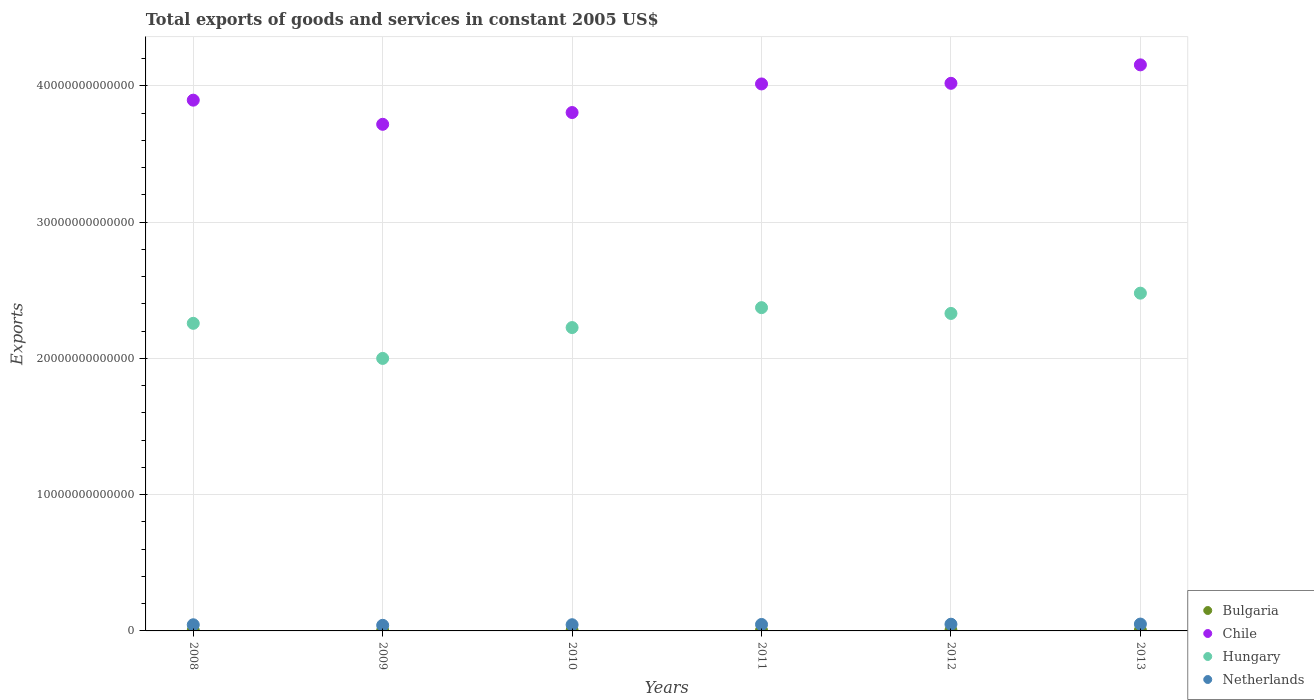How many different coloured dotlines are there?
Give a very brief answer. 4. What is the total exports of goods and services in Netherlands in 2013?
Keep it short and to the point. 5.03e+11. Across all years, what is the maximum total exports of goods and services in Chile?
Provide a short and direct response. 4.15e+13. Across all years, what is the minimum total exports of goods and services in Chile?
Ensure brevity in your answer.  3.72e+13. In which year was the total exports of goods and services in Netherlands maximum?
Provide a short and direct response. 2013. In which year was the total exports of goods and services in Hungary minimum?
Keep it short and to the point. 2009. What is the total total exports of goods and services in Bulgaria in the graph?
Your answer should be compact. 2.49e+11. What is the difference between the total exports of goods and services in Chile in 2012 and that in 2013?
Offer a terse response. -1.35e+12. What is the difference between the total exports of goods and services in Hungary in 2012 and the total exports of goods and services in Netherlands in 2009?
Give a very brief answer. 2.29e+13. What is the average total exports of goods and services in Hungary per year?
Make the answer very short. 2.28e+13. In the year 2012, what is the difference between the total exports of goods and services in Netherlands and total exports of goods and services in Hungary?
Provide a short and direct response. -2.28e+13. In how many years, is the total exports of goods and services in Chile greater than 16000000000000 US$?
Provide a short and direct response. 6. What is the ratio of the total exports of goods and services in Chile in 2009 to that in 2012?
Offer a terse response. 0.93. Is the total exports of goods and services in Netherlands in 2009 less than that in 2011?
Give a very brief answer. Yes. Is the difference between the total exports of goods and services in Netherlands in 2012 and 2013 greater than the difference between the total exports of goods and services in Hungary in 2012 and 2013?
Keep it short and to the point. Yes. What is the difference between the highest and the second highest total exports of goods and services in Bulgaria?
Offer a terse response. 4.09e+09. What is the difference between the highest and the lowest total exports of goods and services in Bulgaria?
Offer a terse response. 1.48e+1. Is the sum of the total exports of goods and services in Hungary in 2008 and 2010 greater than the maximum total exports of goods and services in Netherlands across all years?
Your answer should be compact. Yes. Is it the case that in every year, the sum of the total exports of goods and services in Chile and total exports of goods and services in Hungary  is greater than the total exports of goods and services in Netherlands?
Keep it short and to the point. Yes. Is the total exports of goods and services in Bulgaria strictly greater than the total exports of goods and services in Hungary over the years?
Your response must be concise. No. How many dotlines are there?
Offer a terse response. 4. How many years are there in the graph?
Ensure brevity in your answer.  6. What is the difference between two consecutive major ticks on the Y-axis?
Provide a short and direct response. 1.00e+13. Are the values on the major ticks of Y-axis written in scientific E-notation?
Your answer should be compact. No. Does the graph contain any zero values?
Offer a very short reply. No. Does the graph contain grids?
Ensure brevity in your answer.  Yes. How many legend labels are there?
Your response must be concise. 4. What is the title of the graph?
Your response must be concise. Total exports of goods and services in constant 2005 US$. What is the label or title of the Y-axis?
Provide a short and direct response. Exports. What is the Exports in Bulgaria in 2008?
Keep it short and to the point. 3.83e+1. What is the Exports in Chile in 2008?
Keep it short and to the point. 3.90e+13. What is the Exports of Hungary in 2008?
Your answer should be very brief. 2.26e+13. What is the Exports in Netherlands in 2008?
Offer a very short reply. 4.51e+11. What is the Exports of Bulgaria in 2009?
Ensure brevity in your answer.  3.38e+1. What is the Exports in Chile in 2009?
Ensure brevity in your answer.  3.72e+13. What is the Exports in Hungary in 2009?
Offer a terse response. 2.00e+13. What is the Exports in Netherlands in 2009?
Keep it short and to the point. 4.11e+11. What is the Exports in Bulgaria in 2010?
Offer a very short reply. 3.96e+1. What is the Exports of Chile in 2010?
Your response must be concise. 3.80e+13. What is the Exports in Hungary in 2010?
Give a very brief answer. 2.23e+13. What is the Exports in Netherlands in 2010?
Provide a short and direct response. 4.54e+11. What is the Exports of Bulgaria in 2011?
Your answer should be compact. 4.42e+1. What is the Exports of Chile in 2011?
Your response must be concise. 4.01e+13. What is the Exports in Hungary in 2011?
Give a very brief answer. 2.37e+13. What is the Exports of Netherlands in 2011?
Offer a terse response. 4.74e+11. What is the Exports in Bulgaria in 2012?
Your answer should be compact. 4.46e+1. What is the Exports in Chile in 2012?
Make the answer very short. 4.02e+13. What is the Exports in Hungary in 2012?
Give a very brief answer. 2.33e+13. What is the Exports in Netherlands in 2012?
Your answer should be compact. 4.92e+11. What is the Exports of Bulgaria in 2013?
Ensure brevity in your answer.  4.86e+1. What is the Exports of Chile in 2013?
Your answer should be compact. 4.15e+13. What is the Exports in Hungary in 2013?
Your response must be concise. 2.48e+13. What is the Exports of Netherlands in 2013?
Give a very brief answer. 5.03e+11. Across all years, what is the maximum Exports of Bulgaria?
Offer a very short reply. 4.86e+1. Across all years, what is the maximum Exports of Chile?
Make the answer very short. 4.15e+13. Across all years, what is the maximum Exports of Hungary?
Make the answer very short. 2.48e+13. Across all years, what is the maximum Exports of Netherlands?
Ensure brevity in your answer.  5.03e+11. Across all years, what is the minimum Exports in Bulgaria?
Your answer should be compact. 3.38e+1. Across all years, what is the minimum Exports of Chile?
Provide a succinct answer. 3.72e+13. Across all years, what is the minimum Exports of Hungary?
Keep it short and to the point. 2.00e+13. Across all years, what is the minimum Exports of Netherlands?
Give a very brief answer. 4.11e+11. What is the total Exports of Bulgaria in the graph?
Make the answer very short. 2.49e+11. What is the total Exports in Chile in the graph?
Make the answer very short. 2.36e+14. What is the total Exports of Hungary in the graph?
Your answer should be compact. 1.37e+14. What is the total Exports of Netherlands in the graph?
Make the answer very short. 2.79e+12. What is the difference between the Exports of Bulgaria in 2008 and that in 2009?
Provide a succinct answer. 4.49e+09. What is the difference between the Exports in Chile in 2008 and that in 2009?
Make the answer very short. 1.77e+12. What is the difference between the Exports of Hungary in 2008 and that in 2009?
Provide a short and direct response. 2.58e+12. What is the difference between the Exports in Netherlands in 2008 and that in 2009?
Provide a succinct answer. 4.02e+1. What is the difference between the Exports of Bulgaria in 2008 and that in 2010?
Offer a very short reply. -1.33e+09. What is the difference between the Exports of Chile in 2008 and that in 2010?
Offer a terse response. 9.08e+11. What is the difference between the Exports of Hungary in 2008 and that in 2010?
Your response must be concise. 3.11e+11. What is the difference between the Exports of Netherlands in 2008 and that in 2010?
Provide a short and direct response. -3.14e+09. What is the difference between the Exports in Bulgaria in 2008 and that in 2011?
Your response must be concise. -5.89e+09. What is the difference between the Exports in Chile in 2008 and that in 2011?
Offer a very short reply. -1.19e+12. What is the difference between the Exports of Hungary in 2008 and that in 2011?
Make the answer very short. -1.15e+12. What is the difference between the Exports of Netherlands in 2008 and that in 2011?
Provide a succinct answer. -2.32e+1. What is the difference between the Exports in Bulgaria in 2008 and that in 2012?
Keep it short and to the point. -6.23e+09. What is the difference between the Exports in Chile in 2008 and that in 2012?
Provide a succinct answer. -1.24e+12. What is the difference between the Exports in Hungary in 2008 and that in 2012?
Your response must be concise. -7.25e+11. What is the difference between the Exports in Netherlands in 2008 and that in 2012?
Your answer should be compact. -4.11e+1. What is the difference between the Exports of Bulgaria in 2008 and that in 2013?
Provide a succinct answer. -1.03e+1. What is the difference between the Exports of Chile in 2008 and that in 2013?
Your answer should be very brief. -2.59e+12. What is the difference between the Exports in Hungary in 2008 and that in 2013?
Provide a succinct answer. -2.21e+12. What is the difference between the Exports of Netherlands in 2008 and that in 2013?
Offer a terse response. -5.17e+1. What is the difference between the Exports of Bulgaria in 2009 and that in 2010?
Keep it short and to the point. -5.82e+09. What is the difference between the Exports of Chile in 2009 and that in 2010?
Give a very brief answer. -8.64e+11. What is the difference between the Exports in Hungary in 2009 and that in 2010?
Provide a succinct answer. -2.26e+12. What is the difference between the Exports of Netherlands in 2009 and that in 2010?
Your response must be concise. -4.33e+1. What is the difference between the Exports of Bulgaria in 2009 and that in 2011?
Offer a very short reply. -1.04e+1. What is the difference between the Exports of Chile in 2009 and that in 2011?
Your answer should be very brief. -2.96e+12. What is the difference between the Exports in Hungary in 2009 and that in 2011?
Your response must be concise. -3.73e+12. What is the difference between the Exports of Netherlands in 2009 and that in 2011?
Your answer should be compact. -6.33e+1. What is the difference between the Exports of Bulgaria in 2009 and that in 2012?
Make the answer very short. -1.07e+1. What is the difference between the Exports in Chile in 2009 and that in 2012?
Provide a succinct answer. -3.01e+12. What is the difference between the Exports in Hungary in 2009 and that in 2012?
Provide a succinct answer. -3.30e+12. What is the difference between the Exports in Netherlands in 2009 and that in 2012?
Provide a succinct answer. -8.13e+1. What is the difference between the Exports of Bulgaria in 2009 and that in 2013?
Make the answer very short. -1.48e+1. What is the difference between the Exports in Chile in 2009 and that in 2013?
Your answer should be very brief. -4.36e+12. What is the difference between the Exports in Hungary in 2009 and that in 2013?
Your response must be concise. -4.79e+12. What is the difference between the Exports of Netherlands in 2009 and that in 2013?
Your answer should be very brief. -9.19e+1. What is the difference between the Exports of Bulgaria in 2010 and that in 2011?
Keep it short and to the point. -4.56e+09. What is the difference between the Exports of Chile in 2010 and that in 2011?
Offer a terse response. -2.10e+12. What is the difference between the Exports in Hungary in 2010 and that in 2011?
Your answer should be compact. -1.46e+12. What is the difference between the Exports of Netherlands in 2010 and that in 2011?
Ensure brevity in your answer.  -2.00e+1. What is the difference between the Exports in Bulgaria in 2010 and that in 2012?
Keep it short and to the point. -4.91e+09. What is the difference between the Exports of Chile in 2010 and that in 2012?
Offer a very short reply. -2.14e+12. What is the difference between the Exports of Hungary in 2010 and that in 2012?
Offer a terse response. -1.04e+12. What is the difference between the Exports of Netherlands in 2010 and that in 2012?
Your answer should be very brief. -3.80e+1. What is the difference between the Exports in Bulgaria in 2010 and that in 2013?
Keep it short and to the point. -9.00e+09. What is the difference between the Exports of Chile in 2010 and that in 2013?
Your answer should be compact. -3.50e+12. What is the difference between the Exports of Hungary in 2010 and that in 2013?
Make the answer very short. -2.52e+12. What is the difference between the Exports of Netherlands in 2010 and that in 2013?
Provide a short and direct response. -4.86e+1. What is the difference between the Exports in Bulgaria in 2011 and that in 2012?
Your answer should be very brief. -3.45e+08. What is the difference between the Exports in Chile in 2011 and that in 2012?
Make the answer very short. -4.56e+1. What is the difference between the Exports in Hungary in 2011 and that in 2012?
Ensure brevity in your answer.  4.25e+11. What is the difference between the Exports in Netherlands in 2011 and that in 2012?
Make the answer very short. -1.80e+1. What is the difference between the Exports of Bulgaria in 2011 and that in 2013?
Offer a terse response. -4.44e+09. What is the difference between the Exports of Chile in 2011 and that in 2013?
Your answer should be very brief. -1.40e+12. What is the difference between the Exports of Hungary in 2011 and that in 2013?
Keep it short and to the point. -1.06e+12. What is the difference between the Exports of Netherlands in 2011 and that in 2013?
Your answer should be compact. -2.86e+1. What is the difference between the Exports of Bulgaria in 2012 and that in 2013?
Ensure brevity in your answer.  -4.09e+09. What is the difference between the Exports of Chile in 2012 and that in 2013?
Your answer should be compact. -1.35e+12. What is the difference between the Exports in Hungary in 2012 and that in 2013?
Your response must be concise. -1.49e+12. What is the difference between the Exports in Netherlands in 2012 and that in 2013?
Provide a short and direct response. -1.06e+1. What is the difference between the Exports of Bulgaria in 2008 and the Exports of Chile in 2009?
Your response must be concise. -3.71e+13. What is the difference between the Exports of Bulgaria in 2008 and the Exports of Hungary in 2009?
Your answer should be very brief. -2.00e+13. What is the difference between the Exports in Bulgaria in 2008 and the Exports in Netherlands in 2009?
Make the answer very short. -3.73e+11. What is the difference between the Exports of Chile in 2008 and the Exports of Hungary in 2009?
Make the answer very short. 1.90e+13. What is the difference between the Exports of Chile in 2008 and the Exports of Netherlands in 2009?
Offer a terse response. 3.85e+13. What is the difference between the Exports of Hungary in 2008 and the Exports of Netherlands in 2009?
Your answer should be very brief. 2.22e+13. What is the difference between the Exports of Bulgaria in 2008 and the Exports of Chile in 2010?
Keep it short and to the point. -3.80e+13. What is the difference between the Exports in Bulgaria in 2008 and the Exports in Hungary in 2010?
Make the answer very short. -2.22e+13. What is the difference between the Exports of Bulgaria in 2008 and the Exports of Netherlands in 2010?
Your answer should be very brief. -4.16e+11. What is the difference between the Exports of Chile in 2008 and the Exports of Hungary in 2010?
Your answer should be compact. 1.67e+13. What is the difference between the Exports in Chile in 2008 and the Exports in Netherlands in 2010?
Ensure brevity in your answer.  3.85e+13. What is the difference between the Exports in Hungary in 2008 and the Exports in Netherlands in 2010?
Provide a short and direct response. 2.21e+13. What is the difference between the Exports in Bulgaria in 2008 and the Exports in Chile in 2011?
Provide a short and direct response. -4.01e+13. What is the difference between the Exports of Bulgaria in 2008 and the Exports of Hungary in 2011?
Give a very brief answer. -2.37e+13. What is the difference between the Exports of Bulgaria in 2008 and the Exports of Netherlands in 2011?
Offer a terse response. -4.36e+11. What is the difference between the Exports of Chile in 2008 and the Exports of Hungary in 2011?
Offer a very short reply. 1.52e+13. What is the difference between the Exports of Chile in 2008 and the Exports of Netherlands in 2011?
Provide a short and direct response. 3.85e+13. What is the difference between the Exports of Hungary in 2008 and the Exports of Netherlands in 2011?
Your answer should be very brief. 2.21e+13. What is the difference between the Exports in Bulgaria in 2008 and the Exports in Chile in 2012?
Offer a very short reply. -4.02e+13. What is the difference between the Exports of Bulgaria in 2008 and the Exports of Hungary in 2012?
Give a very brief answer. -2.33e+13. What is the difference between the Exports in Bulgaria in 2008 and the Exports in Netherlands in 2012?
Ensure brevity in your answer.  -4.54e+11. What is the difference between the Exports of Chile in 2008 and the Exports of Hungary in 2012?
Make the answer very short. 1.57e+13. What is the difference between the Exports in Chile in 2008 and the Exports in Netherlands in 2012?
Keep it short and to the point. 3.85e+13. What is the difference between the Exports in Hungary in 2008 and the Exports in Netherlands in 2012?
Provide a short and direct response. 2.21e+13. What is the difference between the Exports in Bulgaria in 2008 and the Exports in Chile in 2013?
Make the answer very short. -4.15e+13. What is the difference between the Exports in Bulgaria in 2008 and the Exports in Hungary in 2013?
Offer a terse response. -2.48e+13. What is the difference between the Exports of Bulgaria in 2008 and the Exports of Netherlands in 2013?
Give a very brief answer. -4.65e+11. What is the difference between the Exports in Chile in 2008 and the Exports in Hungary in 2013?
Ensure brevity in your answer.  1.42e+13. What is the difference between the Exports in Chile in 2008 and the Exports in Netherlands in 2013?
Ensure brevity in your answer.  3.85e+13. What is the difference between the Exports of Hungary in 2008 and the Exports of Netherlands in 2013?
Provide a short and direct response. 2.21e+13. What is the difference between the Exports in Bulgaria in 2009 and the Exports in Chile in 2010?
Your answer should be compact. -3.80e+13. What is the difference between the Exports of Bulgaria in 2009 and the Exports of Hungary in 2010?
Your response must be concise. -2.22e+13. What is the difference between the Exports in Bulgaria in 2009 and the Exports in Netherlands in 2010?
Make the answer very short. -4.21e+11. What is the difference between the Exports of Chile in 2009 and the Exports of Hungary in 2010?
Provide a succinct answer. 1.49e+13. What is the difference between the Exports in Chile in 2009 and the Exports in Netherlands in 2010?
Offer a very short reply. 3.67e+13. What is the difference between the Exports of Hungary in 2009 and the Exports of Netherlands in 2010?
Your answer should be compact. 1.95e+13. What is the difference between the Exports of Bulgaria in 2009 and the Exports of Chile in 2011?
Give a very brief answer. -4.01e+13. What is the difference between the Exports in Bulgaria in 2009 and the Exports in Hungary in 2011?
Offer a terse response. -2.37e+13. What is the difference between the Exports of Bulgaria in 2009 and the Exports of Netherlands in 2011?
Your answer should be very brief. -4.41e+11. What is the difference between the Exports of Chile in 2009 and the Exports of Hungary in 2011?
Offer a very short reply. 1.35e+13. What is the difference between the Exports in Chile in 2009 and the Exports in Netherlands in 2011?
Ensure brevity in your answer.  3.67e+13. What is the difference between the Exports in Hungary in 2009 and the Exports in Netherlands in 2011?
Make the answer very short. 1.95e+13. What is the difference between the Exports in Bulgaria in 2009 and the Exports in Chile in 2012?
Provide a succinct answer. -4.02e+13. What is the difference between the Exports of Bulgaria in 2009 and the Exports of Hungary in 2012?
Provide a short and direct response. -2.33e+13. What is the difference between the Exports of Bulgaria in 2009 and the Exports of Netherlands in 2012?
Your answer should be very brief. -4.59e+11. What is the difference between the Exports in Chile in 2009 and the Exports in Hungary in 2012?
Your answer should be compact. 1.39e+13. What is the difference between the Exports of Chile in 2009 and the Exports of Netherlands in 2012?
Provide a short and direct response. 3.67e+13. What is the difference between the Exports in Hungary in 2009 and the Exports in Netherlands in 2012?
Ensure brevity in your answer.  1.95e+13. What is the difference between the Exports in Bulgaria in 2009 and the Exports in Chile in 2013?
Ensure brevity in your answer.  -4.15e+13. What is the difference between the Exports in Bulgaria in 2009 and the Exports in Hungary in 2013?
Your answer should be very brief. -2.48e+13. What is the difference between the Exports of Bulgaria in 2009 and the Exports of Netherlands in 2013?
Keep it short and to the point. -4.69e+11. What is the difference between the Exports of Chile in 2009 and the Exports of Hungary in 2013?
Provide a short and direct response. 1.24e+13. What is the difference between the Exports of Chile in 2009 and the Exports of Netherlands in 2013?
Provide a succinct answer. 3.67e+13. What is the difference between the Exports of Hungary in 2009 and the Exports of Netherlands in 2013?
Your answer should be very brief. 1.95e+13. What is the difference between the Exports of Bulgaria in 2010 and the Exports of Chile in 2011?
Offer a very short reply. -4.01e+13. What is the difference between the Exports of Bulgaria in 2010 and the Exports of Hungary in 2011?
Provide a short and direct response. -2.37e+13. What is the difference between the Exports in Bulgaria in 2010 and the Exports in Netherlands in 2011?
Make the answer very short. -4.35e+11. What is the difference between the Exports in Chile in 2010 and the Exports in Hungary in 2011?
Provide a succinct answer. 1.43e+13. What is the difference between the Exports of Chile in 2010 and the Exports of Netherlands in 2011?
Provide a short and direct response. 3.76e+13. What is the difference between the Exports in Hungary in 2010 and the Exports in Netherlands in 2011?
Make the answer very short. 2.18e+13. What is the difference between the Exports in Bulgaria in 2010 and the Exports in Chile in 2012?
Provide a succinct answer. -4.01e+13. What is the difference between the Exports in Bulgaria in 2010 and the Exports in Hungary in 2012?
Offer a very short reply. -2.33e+13. What is the difference between the Exports in Bulgaria in 2010 and the Exports in Netherlands in 2012?
Make the answer very short. -4.53e+11. What is the difference between the Exports of Chile in 2010 and the Exports of Hungary in 2012?
Your answer should be very brief. 1.47e+13. What is the difference between the Exports of Chile in 2010 and the Exports of Netherlands in 2012?
Offer a terse response. 3.76e+13. What is the difference between the Exports of Hungary in 2010 and the Exports of Netherlands in 2012?
Provide a short and direct response. 2.18e+13. What is the difference between the Exports of Bulgaria in 2010 and the Exports of Chile in 2013?
Offer a terse response. -4.15e+13. What is the difference between the Exports of Bulgaria in 2010 and the Exports of Hungary in 2013?
Your answer should be very brief. -2.47e+13. What is the difference between the Exports of Bulgaria in 2010 and the Exports of Netherlands in 2013?
Offer a terse response. -4.63e+11. What is the difference between the Exports in Chile in 2010 and the Exports in Hungary in 2013?
Make the answer very short. 1.33e+13. What is the difference between the Exports of Chile in 2010 and the Exports of Netherlands in 2013?
Provide a succinct answer. 3.75e+13. What is the difference between the Exports in Hungary in 2010 and the Exports in Netherlands in 2013?
Provide a short and direct response. 2.18e+13. What is the difference between the Exports of Bulgaria in 2011 and the Exports of Chile in 2012?
Ensure brevity in your answer.  -4.01e+13. What is the difference between the Exports of Bulgaria in 2011 and the Exports of Hungary in 2012?
Make the answer very short. -2.33e+13. What is the difference between the Exports in Bulgaria in 2011 and the Exports in Netherlands in 2012?
Offer a terse response. -4.48e+11. What is the difference between the Exports of Chile in 2011 and the Exports of Hungary in 2012?
Your answer should be compact. 1.68e+13. What is the difference between the Exports in Chile in 2011 and the Exports in Netherlands in 2012?
Ensure brevity in your answer.  3.97e+13. What is the difference between the Exports in Hungary in 2011 and the Exports in Netherlands in 2012?
Your response must be concise. 2.32e+13. What is the difference between the Exports of Bulgaria in 2011 and the Exports of Chile in 2013?
Provide a short and direct response. -4.15e+13. What is the difference between the Exports of Bulgaria in 2011 and the Exports of Hungary in 2013?
Keep it short and to the point. -2.47e+13. What is the difference between the Exports of Bulgaria in 2011 and the Exports of Netherlands in 2013?
Your answer should be compact. -4.59e+11. What is the difference between the Exports in Chile in 2011 and the Exports in Hungary in 2013?
Your answer should be very brief. 1.54e+13. What is the difference between the Exports of Chile in 2011 and the Exports of Netherlands in 2013?
Make the answer very short. 3.96e+13. What is the difference between the Exports in Hungary in 2011 and the Exports in Netherlands in 2013?
Your answer should be compact. 2.32e+13. What is the difference between the Exports of Bulgaria in 2012 and the Exports of Chile in 2013?
Your response must be concise. -4.15e+13. What is the difference between the Exports of Bulgaria in 2012 and the Exports of Hungary in 2013?
Ensure brevity in your answer.  -2.47e+13. What is the difference between the Exports in Bulgaria in 2012 and the Exports in Netherlands in 2013?
Your response must be concise. -4.58e+11. What is the difference between the Exports in Chile in 2012 and the Exports in Hungary in 2013?
Offer a terse response. 1.54e+13. What is the difference between the Exports in Chile in 2012 and the Exports in Netherlands in 2013?
Provide a succinct answer. 3.97e+13. What is the difference between the Exports of Hungary in 2012 and the Exports of Netherlands in 2013?
Offer a very short reply. 2.28e+13. What is the average Exports of Bulgaria per year?
Provide a succinct answer. 4.15e+1. What is the average Exports in Chile per year?
Your answer should be very brief. 3.93e+13. What is the average Exports of Hungary per year?
Offer a very short reply. 2.28e+13. What is the average Exports in Netherlands per year?
Offer a terse response. 4.64e+11. In the year 2008, what is the difference between the Exports of Bulgaria and Exports of Chile?
Offer a very short reply. -3.89e+13. In the year 2008, what is the difference between the Exports in Bulgaria and Exports in Hungary?
Offer a very short reply. -2.25e+13. In the year 2008, what is the difference between the Exports of Bulgaria and Exports of Netherlands?
Your response must be concise. -4.13e+11. In the year 2008, what is the difference between the Exports of Chile and Exports of Hungary?
Give a very brief answer. 1.64e+13. In the year 2008, what is the difference between the Exports of Chile and Exports of Netherlands?
Offer a terse response. 3.85e+13. In the year 2008, what is the difference between the Exports of Hungary and Exports of Netherlands?
Provide a succinct answer. 2.21e+13. In the year 2009, what is the difference between the Exports in Bulgaria and Exports in Chile?
Your answer should be very brief. -3.71e+13. In the year 2009, what is the difference between the Exports of Bulgaria and Exports of Hungary?
Your answer should be very brief. -2.00e+13. In the year 2009, what is the difference between the Exports in Bulgaria and Exports in Netherlands?
Make the answer very short. -3.77e+11. In the year 2009, what is the difference between the Exports in Chile and Exports in Hungary?
Your response must be concise. 1.72e+13. In the year 2009, what is the difference between the Exports of Chile and Exports of Netherlands?
Give a very brief answer. 3.68e+13. In the year 2009, what is the difference between the Exports of Hungary and Exports of Netherlands?
Provide a succinct answer. 1.96e+13. In the year 2010, what is the difference between the Exports in Bulgaria and Exports in Chile?
Provide a short and direct response. -3.80e+13. In the year 2010, what is the difference between the Exports of Bulgaria and Exports of Hungary?
Give a very brief answer. -2.22e+13. In the year 2010, what is the difference between the Exports in Bulgaria and Exports in Netherlands?
Keep it short and to the point. -4.15e+11. In the year 2010, what is the difference between the Exports in Chile and Exports in Hungary?
Your answer should be very brief. 1.58e+13. In the year 2010, what is the difference between the Exports of Chile and Exports of Netherlands?
Your response must be concise. 3.76e+13. In the year 2010, what is the difference between the Exports in Hungary and Exports in Netherlands?
Keep it short and to the point. 2.18e+13. In the year 2011, what is the difference between the Exports in Bulgaria and Exports in Chile?
Provide a short and direct response. -4.01e+13. In the year 2011, what is the difference between the Exports of Bulgaria and Exports of Hungary?
Offer a terse response. -2.37e+13. In the year 2011, what is the difference between the Exports in Bulgaria and Exports in Netherlands?
Your answer should be very brief. -4.30e+11. In the year 2011, what is the difference between the Exports of Chile and Exports of Hungary?
Your answer should be compact. 1.64e+13. In the year 2011, what is the difference between the Exports in Chile and Exports in Netherlands?
Keep it short and to the point. 3.97e+13. In the year 2011, what is the difference between the Exports in Hungary and Exports in Netherlands?
Provide a succinct answer. 2.33e+13. In the year 2012, what is the difference between the Exports of Bulgaria and Exports of Chile?
Provide a short and direct response. -4.01e+13. In the year 2012, what is the difference between the Exports in Bulgaria and Exports in Hungary?
Your answer should be very brief. -2.33e+13. In the year 2012, what is the difference between the Exports of Bulgaria and Exports of Netherlands?
Keep it short and to the point. -4.48e+11. In the year 2012, what is the difference between the Exports of Chile and Exports of Hungary?
Your response must be concise. 1.69e+13. In the year 2012, what is the difference between the Exports in Chile and Exports in Netherlands?
Your answer should be compact. 3.97e+13. In the year 2012, what is the difference between the Exports in Hungary and Exports in Netherlands?
Give a very brief answer. 2.28e+13. In the year 2013, what is the difference between the Exports of Bulgaria and Exports of Chile?
Make the answer very short. -4.15e+13. In the year 2013, what is the difference between the Exports of Bulgaria and Exports of Hungary?
Offer a very short reply. -2.47e+13. In the year 2013, what is the difference between the Exports of Bulgaria and Exports of Netherlands?
Your answer should be compact. -4.54e+11. In the year 2013, what is the difference between the Exports of Chile and Exports of Hungary?
Your answer should be very brief. 1.68e+13. In the year 2013, what is the difference between the Exports of Chile and Exports of Netherlands?
Your answer should be compact. 4.10e+13. In the year 2013, what is the difference between the Exports of Hungary and Exports of Netherlands?
Make the answer very short. 2.43e+13. What is the ratio of the Exports in Bulgaria in 2008 to that in 2009?
Provide a succinct answer. 1.13. What is the ratio of the Exports in Chile in 2008 to that in 2009?
Offer a terse response. 1.05. What is the ratio of the Exports of Hungary in 2008 to that in 2009?
Make the answer very short. 1.13. What is the ratio of the Exports of Netherlands in 2008 to that in 2009?
Offer a terse response. 1.1. What is the ratio of the Exports of Bulgaria in 2008 to that in 2010?
Ensure brevity in your answer.  0.97. What is the ratio of the Exports of Chile in 2008 to that in 2010?
Keep it short and to the point. 1.02. What is the ratio of the Exports of Netherlands in 2008 to that in 2010?
Your answer should be compact. 0.99. What is the ratio of the Exports of Bulgaria in 2008 to that in 2011?
Your response must be concise. 0.87. What is the ratio of the Exports of Chile in 2008 to that in 2011?
Provide a succinct answer. 0.97. What is the ratio of the Exports of Hungary in 2008 to that in 2011?
Make the answer very short. 0.95. What is the ratio of the Exports in Netherlands in 2008 to that in 2011?
Give a very brief answer. 0.95. What is the ratio of the Exports in Bulgaria in 2008 to that in 2012?
Provide a succinct answer. 0.86. What is the ratio of the Exports in Chile in 2008 to that in 2012?
Give a very brief answer. 0.97. What is the ratio of the Exports in Hungary in 2008 to that in 2012?
Keep it short and to the point. 0.97. What is the ratio of the Exports in Netherlands in 2008 to that in 2012?
Offer a terse response. 0.92. What is the ratio of the Exports in Bulgaria in 2008 to that in 2013?
Your answer should be compact. 0.79. What is the ratio of the Exports in Chile in 2008 to that in 2013?
Ensure brevity in your answer.  0.94. What is the ratio of the Exports in Hungary in 2008 to that in 2013?
Your answer should be very brief. 0.91. What is the ratio of the Exports of Netherlands in 2008 to that in 2013?
Provide a short and direct response. 0.9. What is the ratio of the Exports in Bulgaria in 2009 to that in 2010?
Keep it short and to the point. 0.85. What is the ratio of the Exports in Chile in 2009 to that in 2010?
Offer a terse response. 0.98. What is the ratio of the Exports of Hungary in 2009 to that in 2010?
Make the answer very short. 0.9. What is the ratio of the Exports in Netherlands in 2009 to that in 2010?
Ensure brevity in your answer.  0.9. What is the ratio of the Exports in Bulgaria in 2009 to that in 2011?
Keep it short and to the point. 0.77. What is the ratio of the Exports of Chile in 2009 to that in 2011?
Your answer should be compact. 0.93. What is the ratio of the Exports in Hungary in 2009 to that in 2011?
Make the answer very short. 0.84. What is the ratio of the Exports of Netherlands in 2009 to that in 2011?
Offer a very short reply. 0.87. What is the ratio of the Exports in Bulgaria in 2009 to that in 2012?
Your response must be concise. 0.76. What is the ratio of the Exports in Chile in 2009 to that in 2012?
Make the answer very short. 0.93. What is the ratio of the Exports of Hungary in 2009 to that in 2012?
Your answer should be compact. 0.86. What is the ratio of the Exports in Netherlands in 2009 to that in 2012?
Offer a very short reply. 0.83. What is the ratio of the Exports of Bulgaria in 2009 to that in 2013?
Ensure brevity in your answer.  0.7. What is the ratio of the Exports of Chile in 2009 to that in 2013?
Provide a short and direct response. 0.9. What is the ratio of the Exports of Hungary in 2009 to that in 2013?
Provide a succinct answer. 0.81. What is the ratio of the Exports of Netherlands in 2009 to that in 2013?
Offer a very short reply. 0.82. What is the ratio of the Exports in Bulgaria in 2010 to that in 2011?
Keep it short and to the point. 0.9. What is the ratio of the Exports in Chile in 2010 to that in 2011?
Your response must be concise. 0.95. What is the ratio of the Exports in Hungary in 2010 to that in 2011?
Give a very brief answer. 0.94. What is the ratio of the Exports of Netherlands in 2010 to that in 2011?
Offer a very short reply. 0.96. What is the ratio of the Exports of Bulgaria in 2010 to that in 2012?
Offer a very short reply. 0.89. What is the ratio of the Exports of Chile in 2010 to that in 2012?
Your answer should be compact. 0.95. What is the ratio of the Exports of Hungary in 2010 to that in 2012?
Your response must be concise. 0.96. What is the ratio of the Exports in Netherlands in 2010 to that in 2012?
Offer a terse response. 0.92. What is the ratio of the Exports of Bulgaria in 2010 to that in 2013?
Your answer should be compact. 0.81. What is the ratio of the Exports of Chile in 2010 to that in 2013?
Make the answer very short. 0.92. What is the ratio of the Exports in Hungary in 2010 to that in 2013?
Your response must be concise. 0.9. What is the ratio of the Exports in Netherlands in 2010 to that in 2013?
Ensure brevity in your answer.  0.9. What is the ratio of the Exports of Bulgaria in 2011 to that in 2012?
Give a very brief answer. 0.99. What is the ratio of the Exports of Hungary in 2011 to that in 2012?
Offer a very short reply. 1.02. What is the ratio of the Exports of Netherlands in 2011 to that in 2012?
Your answer should be compact. 0.96. What is the ratio of the Exports in Bulgaria in 2011 to that in 2013?
Your response must be concise. 0.91. What is the ratio of the Exports of Chile in 2011 to that in 2013?
Provide a succinct answer. 0.97. What is the ratio of the Exports in Hungary in 2011 to that in 2013?
Provide a short and direct response. 0.96. What is the ratio of the Exports of Netherlands in 2011 to that in 2013?
Provide a short and direct response. 0.94. What is the ratio of the Exports of Bulgaria in 2012 to that in 2013?
Offer a terse response. 0.92. What is the ratio of the Exports in Chile in 2012 to that in 2013?
Give a very brief answer. 0.97. What is the ratio of the Exports of Hungary in 2012 to that in 2013?
Keep it short and to the point. 0.94. What is the ratio of the Exports in Netherlands in 2012 to that in 2013?
Provide a succinct answer. 0.98. What is the difference between the highest and the second highest Exports of Bulgaria?
Keep it short and to the point. 4.09e+09. What is the difference between the highest and the second highest Exports of Chile?
Keep it short and to the point. 1.35e+12. What is the difference between the highest and the second highest Exports in Hungary?
Your answer should be compact. 1.06e+12. What is the difference between the highest and the second highest Exports in Netherlands?
Offer a very short reply. 1.06e+1. What is the difference between the highest and the lowest Exports in Bulgaria?
Keep it short and to the point. 1.48e+1. What is the difference between the highest and the lowest Exports of Chile?
Provide a short and direct response. 4.36e+12. What is the difference between the highest and the lowest Exports of Hungary?
Ensure brevity in your answer.  4.79e+12. What is the difference between the highest and the lowest Exports in Netherlands?
Your answer should be compact. 9.19e+1. 